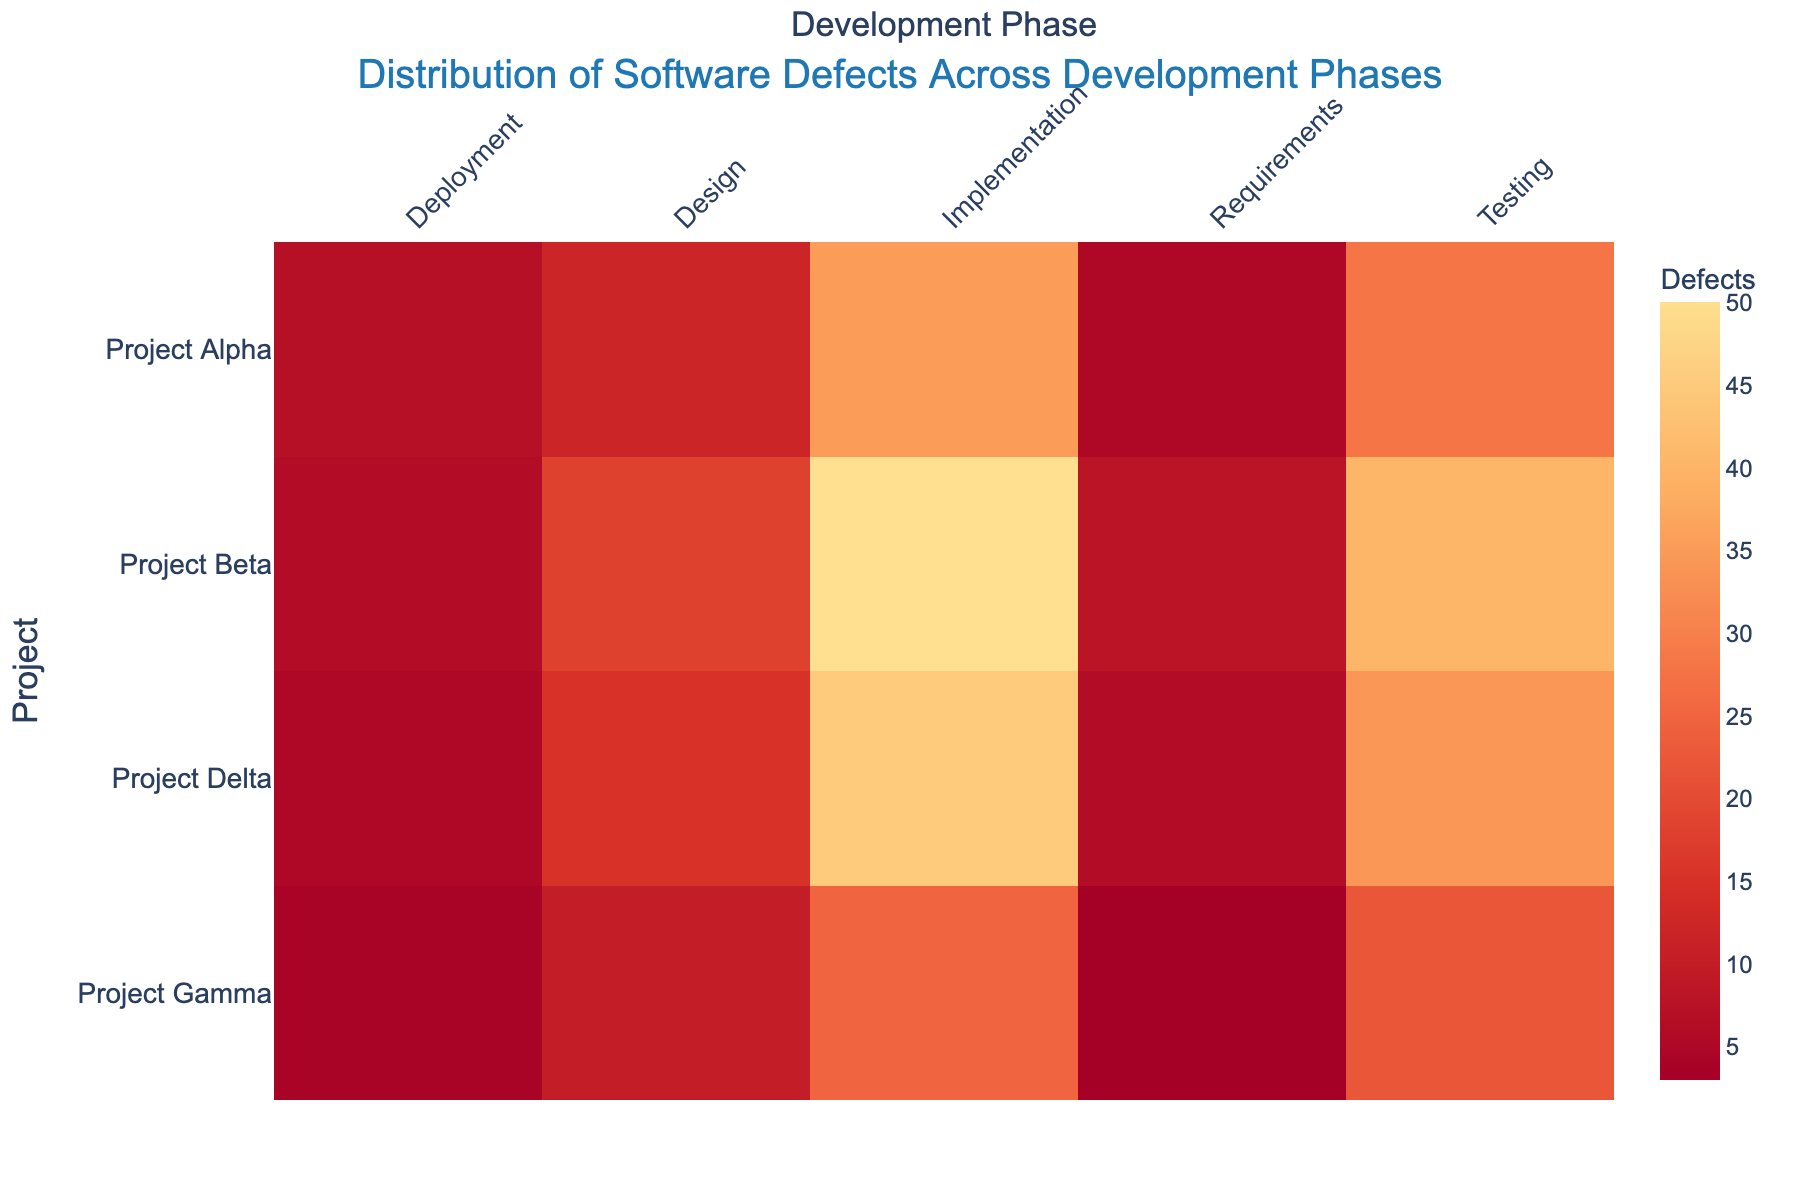Which project has the highest number of defects in the Implementation phase? Look at the cell corresponding to the Implementation phase and find the project with the highest value. Project Beta has the highest value, 50 defects.
Answer: Project Beta What is the total number of defects for Project Alpha across all phases? Sum the number of defects in each phase for Project Alpha: 5 (Requirements) + 12 (Design) + 35 (Implementation) + 28 (Testing) + 7 (Deployment) = 87.
Answer: 87 Which development phase generally has the most defects across all projects? Compare the total defects in each phase by summing the corresponding cell values: Requirements (5+8+3+6=22), Design (12+18+10+15=55), Implementation (35+50+25+45=155), Testing (28+40+22+34=124), Deployment (7+6+4+5=22). Implementation has the highest total defects.
Answer: Implementation How many more defects does Project Beta have in the Testing phase compared to Project Gamma? Subtract the number of defects in the Testing phase of Project Gamma (22) from Project Beta (40): 40 - 22 = 18.
Answer: 18 Which project has the lowest number of defects in the Deployment phase? Identify the smallest value in the Deployment phase column. Project Gamma has the lowest value with 4 defects.
Answer: Project Gamma Between Projects Alpha and Delta, which one has more defects in the Design phase? Compare the values in the Design phase: Project Alpha (12) and Project Delta (15). Project Delta has more defects.
Answer: Project Delta Are the defects in the Requirements phase uniformly distributed across all projects? Check the variation in the values across the Requirements phase: Project Alpha (5), Project Beta (8), Project Gamma (3), Project Delta (6). The defects are not uniformly distributed as they vary significantly.
Answer: No What is the average number of defects in the Testing phase for all projects? Calculate the average by summing the number of defects in the Testing phase and dividing by the number of projects: (28+40+22+34) / 4 = 124 / 4 = 31.
Answer: 31 Which project has seen a reduction in defects from the Testing phase to the Deployment phase? Compare the defects in the Testing and Deployment phases for each project: Project Alpha (28 to 7), Project Beta (40 to 6), Project Gamma (22 to 4), Project Delta (34 to 5). All projects show a reduction, but Project Beta has the largest reduction.
Answer: Project Beta What is the difference in total defects between Project Alpha and Project Delta? Calculate the total defects for Project Alpha (5+12+35+28+7 = 87) and Project Delta (6+15+45+34+5 = 105). Find the difference: 105 - 87 = 18.
Answer: 18 